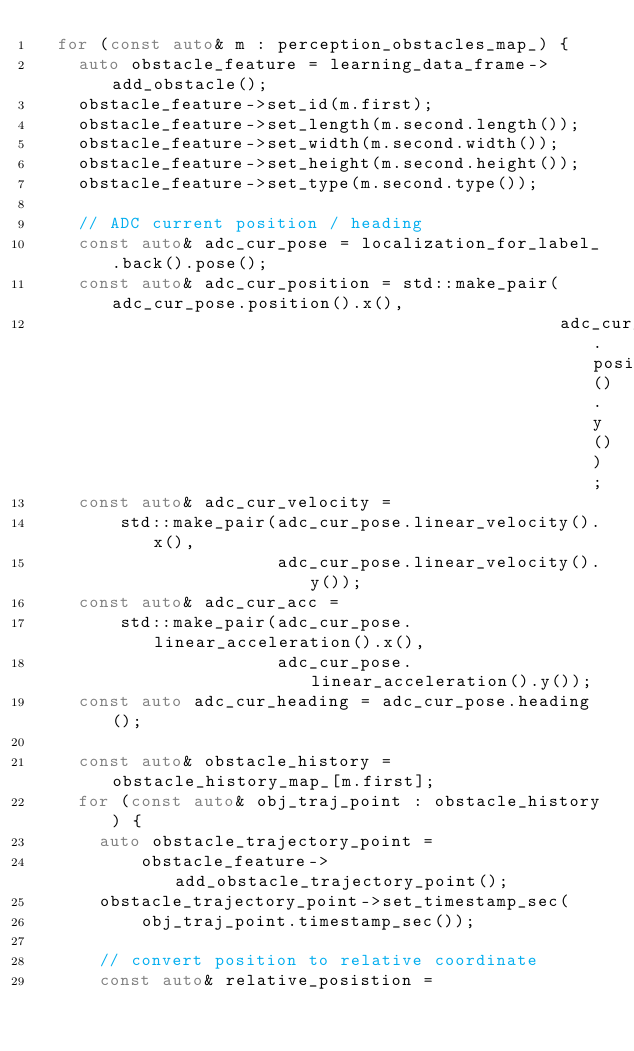Convert code to text. <code><loc_0><loc_0><loc_500><loc_500><_C++_>  for (const auto& m : perception_obstacles_map_) {
    auto obstacle_feature = learning_data_frame->add_obstacle();
    obstacle_feature->set_id(m.first);
    obstacle_feature->set_length(m.second.length());
    obstacle_feature->set_width(m.second.width());
    obstacle_feature->set_height(m.second.height());
    obstacle_feature->set_type(m.second.type());

    // ADC current position / heading
    const auto& adc_cur_pose = localization_for_label_.back().pose();
    const auto& adc_cur_position = std::make_pair(adc_cur_pose.position().x(),
                                                  adc_cur_pose.position().y());
    const auto& adc_cur_velocity =
        std::make_pair(adc_cur_pose.linear_velocity().x(),
                       adc_cur_pose.linear_velocity().y());
    const auto& adc_cur_acc =
        std::make_pair(adc_cur_pose.linear_acceleration().x(),
                       adc_cur_pose.linear_acceleration().y());
    const auto adc_cur_heading = adc_cur_pose.heading();

    const auto& obstacle_history = obstacle_history_map_[m.first];
    for (const auto& obj_traj_point : obstacle_history) {
      auto obstacle_trajectory_point =
          obstacle_feature->add_obstacle_trajectory_point();
      obstacle_trajectory_point->set_timestamp_sec(
          obj_traj_point.timestamp_sec());

      // convert position to relative coordinate
      const auto& relative_posistion =</code> 